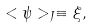Convert formula to latex. <formula><loc_0><loc_0><loc_500><loc_500>< \psi > _ { J } \equiv \xi ,</formula> 